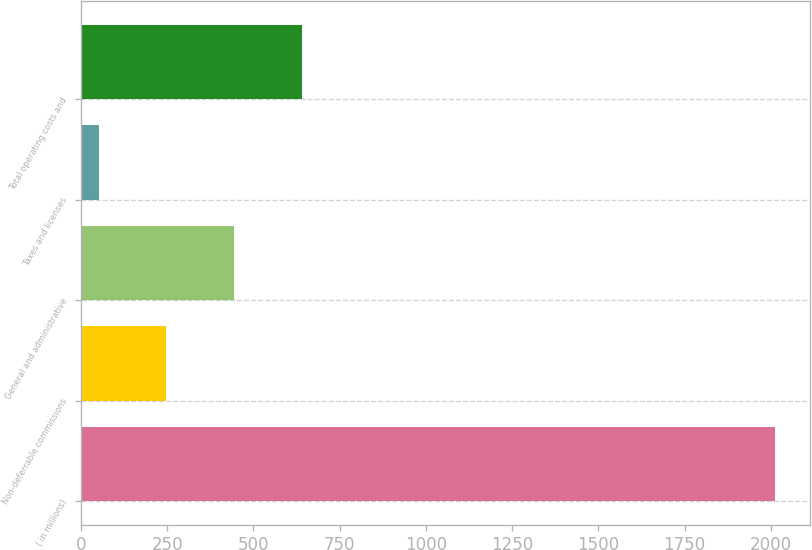<chart> <loc_0><loc_0><loc_500><loc_500><bar_chart><fcel>( in millions)<fcel>Non-deferrable commissions<fcel>General and administrative<fcel>Taxes and licenses<fcel>Total operating costs and<nl><fcel>2012<fcel>248<fcel>444<fcel>52<fcel>640<nl></chart> 